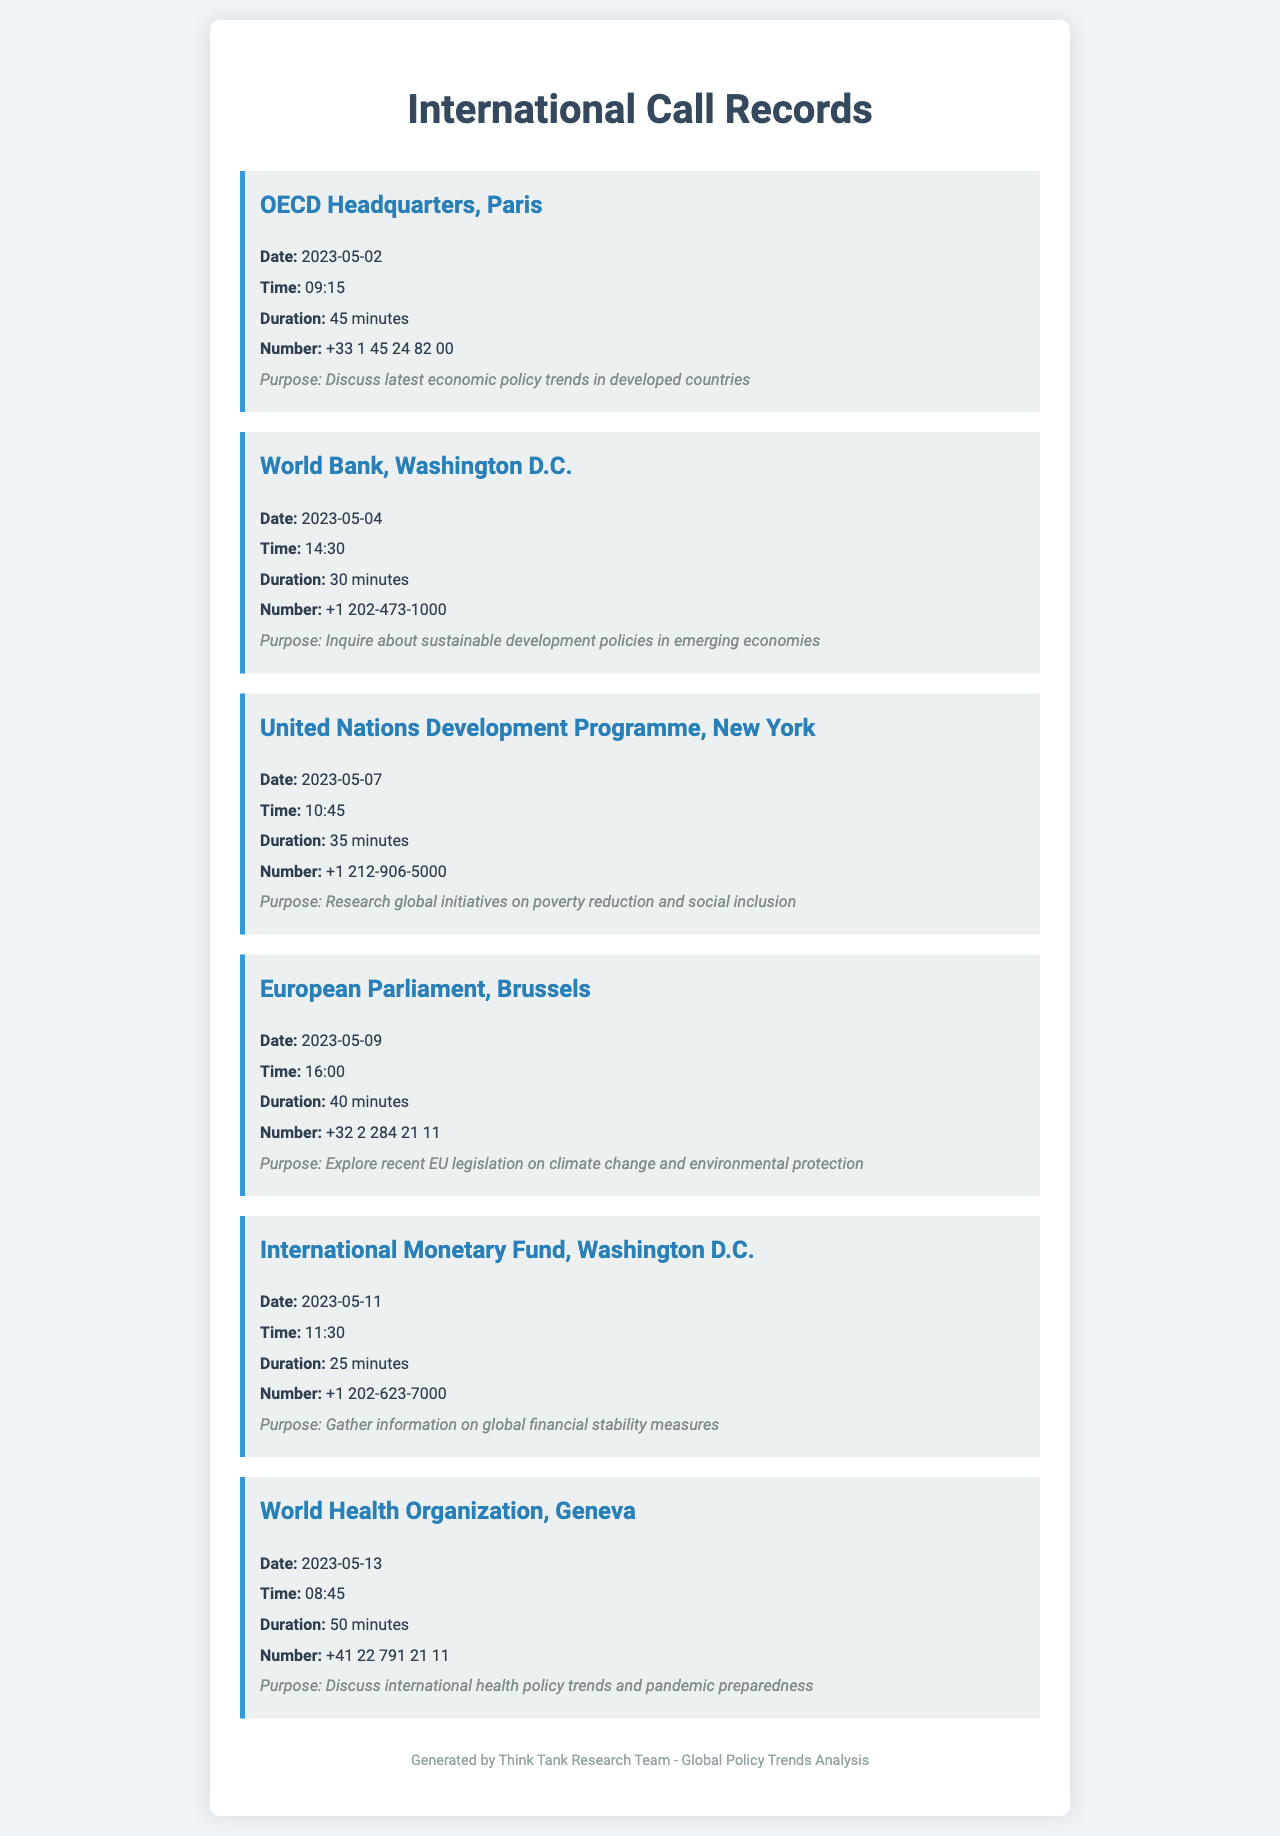What is the duration of the call to OECD Headquarters? The duration is specified in the document as 45 minutes for the call to OECD Headquarters.
Answer: 45 minutes Who was called on May 4, 2023? The document lists the World Bank in Washington D.C. as the organization called on that date.
Answer: World Bank, Washington D.C What was the purpose of the call to the International Monetary Fund? The purpose described in the document is to gather information on global financial stability measures.
Answer: Gather information on global financial stability measures How many minutes was the call to the World Health Organization? The call duration is given in the document as 50 minutes for the World Health Organization.
Answer: 50 minutes When did the call to the European Parliament take place? The document specifies the call took place on May 9, 2023.
Answer: May 9, 2023 Which organization was contacted to discuss health policy trends? The organization mentioned in the document for discussing health policy trends is the World Health Organization.
Answer: World Health Organization What time was the call made to the United Nations Development Programme? The document states the time of the call to the UNDP was 10:45.
Answer: 10:45 What is the phone number for the call to OECD Headquarters? The document provides the number as +33 1 45 24 82 00 for the OECD Headquarters call.
Answer: +33 1 45 24 82 00 How many international calls were made according to the document? The document lists a total of six international calls made.
Answer: Six 